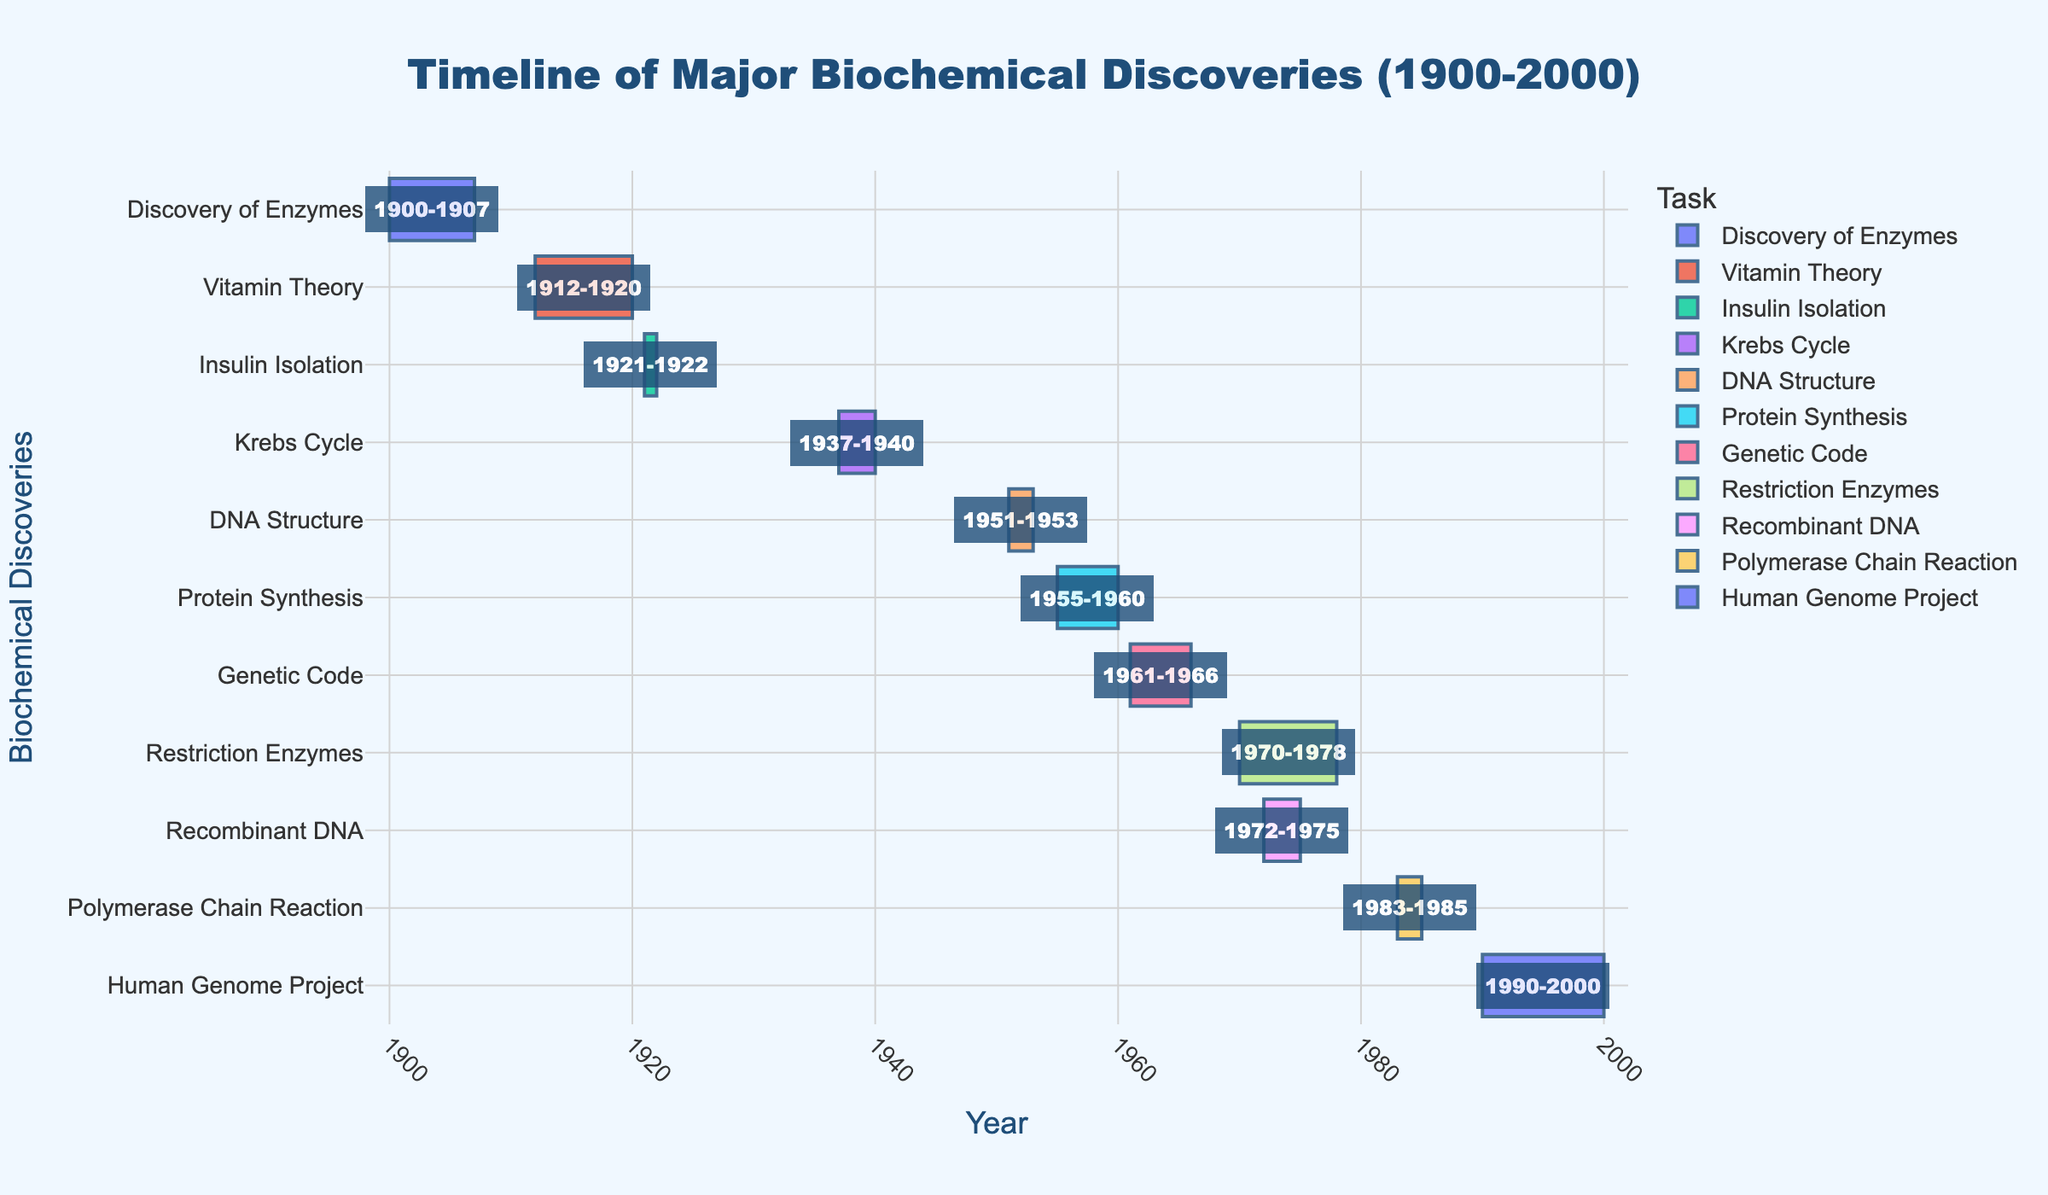What is the total span of the timeline in the figure? To determine the total span, identify the earliest start year and the latest end year. The earliest start year is 1900 (Discovery of Enzymes) and the latest end year is 2000 (Human Genome Project). Subtract 1900 from 2000.
Answer: 100 years Which discovery spans the longest period on the timeline? To find the discovery spanning the longest period, compare the duration (end year minus start year) of each discovery. The Human Genome Project spans the longest period from 1990 to 2000, which is 10 years.
Answer: Human Genome Project How many discoveries took place between 1950 and 2000? To count the discoveries between 1950 and 2000, review the start and end years of each task and select those fitting within this range. The tasks are DNA Structure (1951-1953), Protein Synthesis (1955-1960), Genetic Code (1961-1966), Restriction Enzymes (1970-1978), Recombinant DNA (1972-1975), Polymerase Chain Reaction (1983-1985), and Human Genome Project (1990-2000).
Answer: 7 Which discoveries overlapped with each other time-wise? To identify overlapping discoveries, look at the periods (start-to-end) for each task and check if they coincide. Overlapping discoveries are: Vitamin Theory (1912-1920) and Discovery of Enzymes (1900-1907); DNA Structure (1951-1953), Protein Synthesis (1955-1960), and Genetic Code (1961-1966); Restriction Enzymes (1970-1978) and Recombinant DNA (1972-1975); and Polymerase Chain Reaction (1983-1985) and Human Genome Project (1990-2000).
Answer: Several overlaps as explained What is the median start year of the discoveries? List the start years, sort them in ascending order: 1900, 1912, 1921, 1937, 1951, 1955, 1961, 1970, 1972, 1983, 1990. The middle value (median) in this sorted list is 1955.
Answer: 1955 